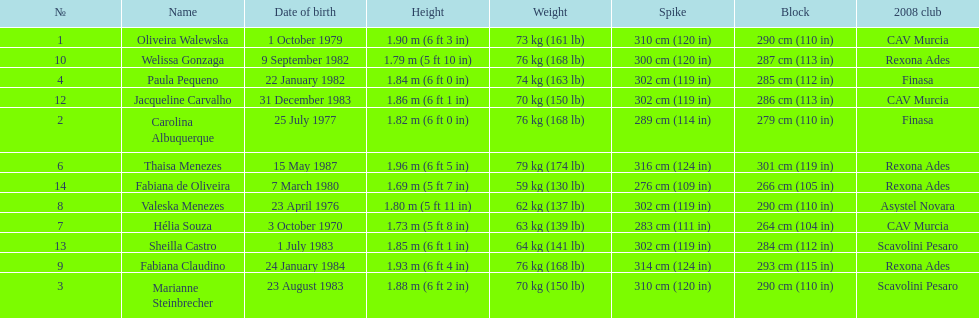Which player is the shortest at only 5 ft 7 in? Fabiana de Oliveira. 